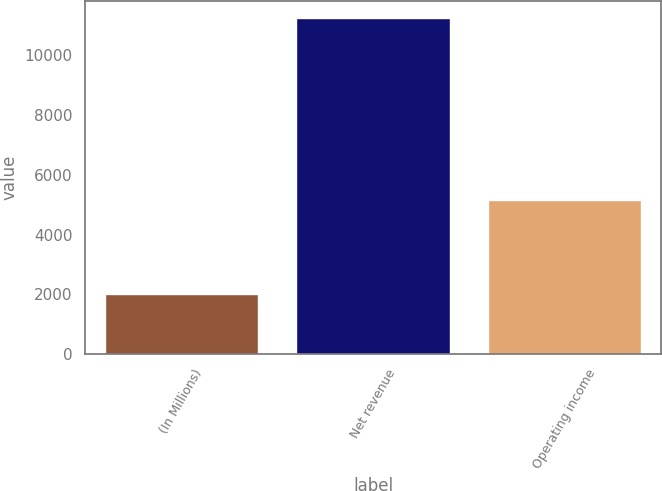Convert chart. <chart><loc_0><loc_0><loc_500><loc_500><bar_chart><fcel>(In Millions)<fcel>Net revenue<fcel>Operating income<nl><fcel>2013<fcel>11238<fcel>5164<nl></chart> 